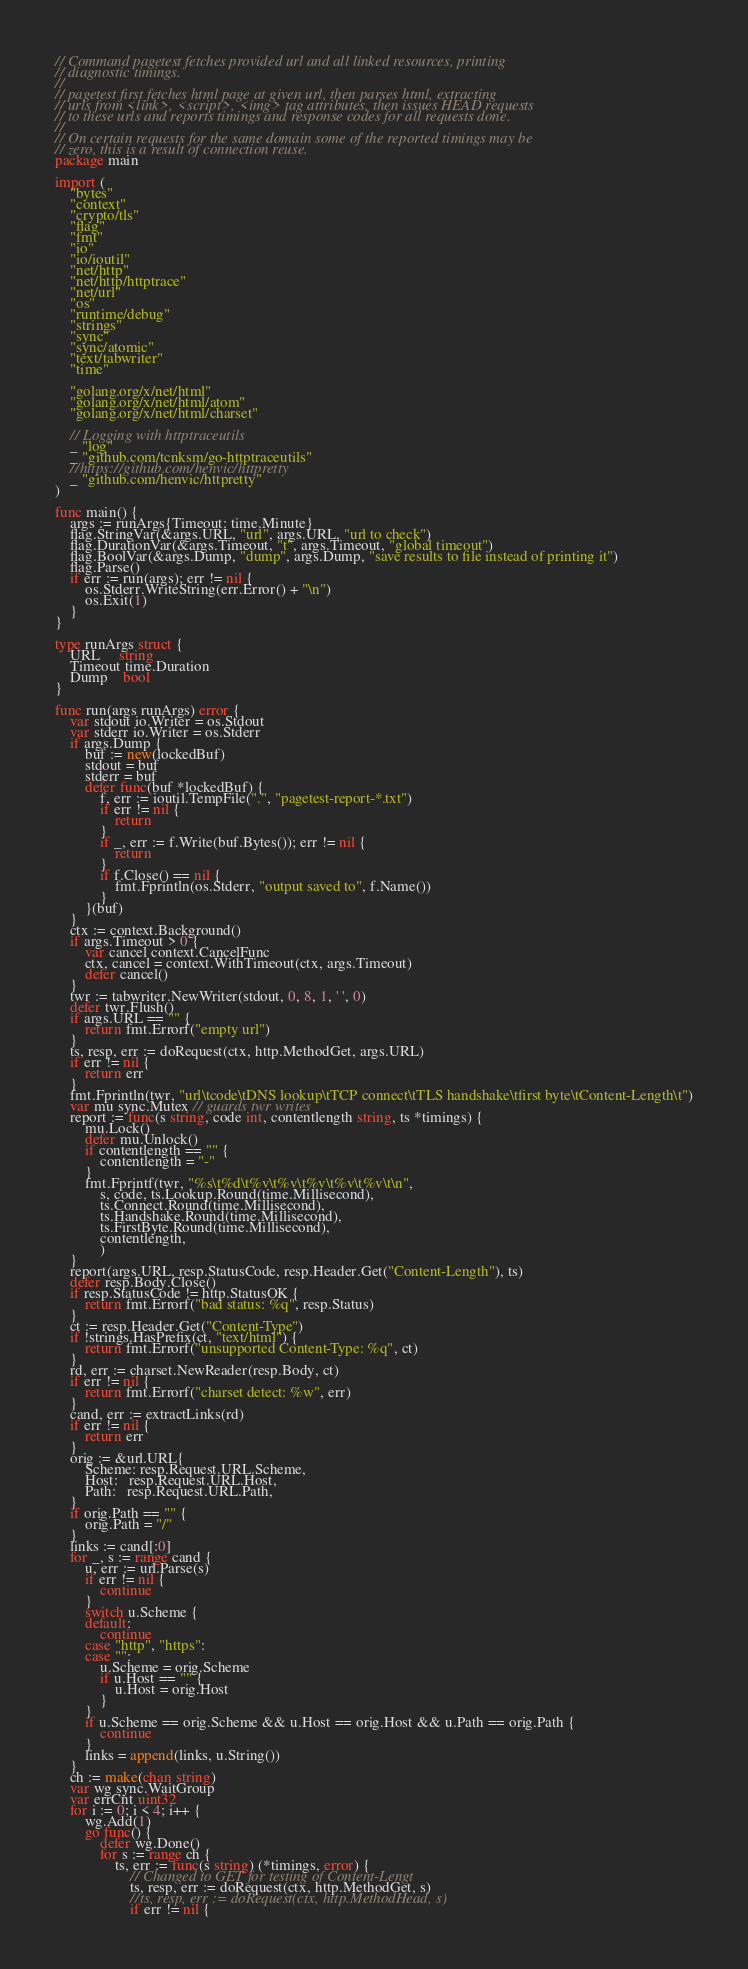<code> <loc_0><loc_0><loc_500><loc_500><_Go_>// Command pagetest fetches provided url and all linked resources, printing
// diagnostic timings.
//
// pagetest first fetches html page at given url, then parses html, extracting
// urls from <link>, <script>, <img> tag attributes, then issues HEAD requests
// to these urls and reports timings and response codes for all requests done.
//
// On certain requests for the same domain some of the reported timings may be
// zero, this is a result of connection reuse.
package main

import (
	"bytes"
	"context"
	"crypto/tls"
	"flag"
	"fmt"
	"io"
	"io/ioutil"
	"net/http"
	"net/http/httptrace"
	"net/url"
	"os"
	"runtime/debug"
	"strings"
	"sync"
	"sync/atomic"
	"text/tabwriter"
	"time"

	"golang.org/x/net/html"
	"golang.org/x/net/html/atom"
	"golang.org/x/net/html/charset"

    // Logging with httptraceutils
    _ "log"
	_ "github.com/tcnksm/go-httptraceutils"
    //https://github.com/henvic/httpretty
	_ "github.com/henvic/httpretty"
)

func main() {
	args := runArgs{Timeout: time.Minute}
	flag.StringVar(&args.URL, "url", args.URL, "url to check")
	flag.DurationVar(&args.Timeout, "t", args.Timeout, "global timeout")
	flag.BoolVar(&args.Dump, "dump", args.Dump, "save results to file instead of printing it")
	flag.Parse()
	if err := run(args); err != nil {
		os.Stderr.WriteString(err.Error() + "\n")
		os.Exit(1)
	}
}

type runArgs struct {
	URL     string
	Timeout time.Duration
	Dump    bool
}

func run(args runArgs) error {
	var stdout io.Writer = os.Stdout
	var stderr io.Writer = os.Stderr
	if args.Dump {
		buf := new(lockedBuf)
		stdout = buf
		stderr = buf
		defer func(buf *lockedBuf) {
			f, err := ioutil.TempFile(".", "pagetest-report-*.txt")
			if err != nil {
				return
			}
			if _, err := f.Write(buf.Bytes()); err != nil {
				return
			}
			if f.Close() == nil {
				fmt.Fprintln(os.Stderr, "output saved to", f.Name())
			}
		}(buf)
	}
	ctx := context.Background()
	if args.Timeout > 0 {
		var cancel context.CancelFunc
		ctx, cancel = context.WithTimeout(ctx, args.Timeout)
		defer cancel()
	}
	twr := tabwriter.NewWriter(stdout, 0, 8, 1, ' ', 0)
	defer twr.Flush()
	if args.URL == "" {
		return fmt.Errorf("empty url")
	}
	ts, resp, err := doRequest(ctx, http.MethodGet, args.URL)
	if err != nil {
		return err
	}
	fmt.Fprintln(twr, "url\tcode\tDNS lookup\tTCP connect\tTLS handshake\tfirst byte\tContent-Length\t")
	var mu sync.Mutex // guards twr writes
	report := func(s string, code int, contentlength string, ts *timings) {
		mu.Lock()
		defer mu.Unlock()
        if contentlength == "" {
    		contentlength = "-"
        }
		fmt.Fprintf(twr, "%s\t%d\t%v\t%v\t%v\t%v\t%v\t\n",
			s, code, ts.Lookup.Round(time.Millisecond),
			ts.Connect.Round(time.Millisecond),
			ts.Handshake.Round(time.Millisecond),
			ts.FirstByte.Round(time.Millisecond),
            contentlength,
            )
	}
	report(args.URL, resp.StatusCode, resp.Header.Get("Content-Length"), ts)
	defer resp.Body.Close()
	if resp.StatusCode != http.StatusOK {
		return fmt.Errorf("bad status: %q", resp.Status)
	}
	ct := resp.Header.Get("Content-Type")
	if !strings.HasPrefix(ct, "text/html") {
		return fmt.Errorf("unsupported Content-Type: %q", ct)
	}
	rd, err := charset.NewReader(resp.Body, ct)
	if err != nil {
		return fmt.Errorf("charset detect: %w", err)
	}
	cand, err := extractLinks(rd)
	if err != nil {
		return err
	}
	orig := &url.URL{
		Scheme: resp.Request.URL.Scheme,
		Host:   resp.Request.URL.Host,
		Path:   resp.Request.URL.Path,
	}
	if orig.Path == "" {
		orig.Path = "/"
	}
	links := cand[:0]
	for _, s := range cand {
		u, err := url.Parse(s)
		if err != nil {
			continue
		}
		switch u.Scheme {
		default:
			continue
		case "http", "https":
		case "":
			u.Scheme = orig.Scheme
			if u.Host == "" {
				u.Host = orig.Host
			}
		}
		if u.Scheme == orig.Scheme && u.Host == orig.Host && u.Path == orig.Path {
			continue
		}
		links = append(links, u.String())
	}
	ch := make(chan string)
	var wg sync.WaitGroup
	var errCnt uint32
	for i := 0; i < 4; i++ {
		wg.Add(1)
		go func() {
			defer wg.Done()
			for s := range ch {
				ts, err := func(s string) (*timings, error) {
					// Changed to GET for testing of Content-Lengt
					ts, resp, err := doRequest(ctx, http.MethodGet, s)
					//ts, resp, err := doRequest(ctx, http.MethodHead, s)
					if err != nil {</code> 